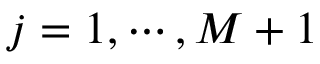<formula> <loc_0><loc_0><loc_500><loc_500>j = 1 , \cdots , M + 1</formula> 